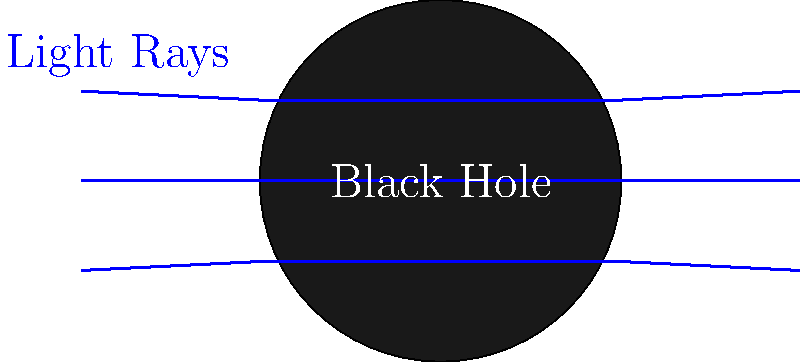In the context of non-Euclidean geometry, what phenomenon is illustrated by the bending of light rays around the black hole in this diagram, and how does it relate to the concept of straight lines in curved space-time? To understand this phenomenon, let's break it down step-by-step:

1. In Euclidean geometry, light rays would travel in straight lines. However, the diagram shows light rays bending around the black hole.

2. This bending of light is a result of the gravitational lensing effect, which is a consequence of Einstein's theory of general relativity.

3. In general relativity, massive objects like black holes warp the fabric of space-time around them.

4. Light follows the shortest path through space-time, which we perceive as a straight line in flat space.

5. However, in curved space-time near a black hole, the shortest path is no longer a straight line in our classical understanding.

6. The paths of light rays in the diagram represent geodesics - the equivalent of "straight lines" in curved space-time.

7. This phenomenon demonstrates that in non-Euclidean geometry, particularly in the curved space-time around massive objects, our intuitive notion of straight lines needs to be revised.

8. The bending of light rays is not just a theoretical concept - it has been observed in reality, such as during solar eclipses when stars appear to be in different positions due to the Sun's gravitational lensing effect.

In essence, this diagram illustrates how the concept of "straight" in non-Euclidean geometry can differ significantly from our Euclidean intuition, especially in the presence of strong gravitational fields.
Answer: Gravitational lensing, demonstrating geodesics in curved space-time 